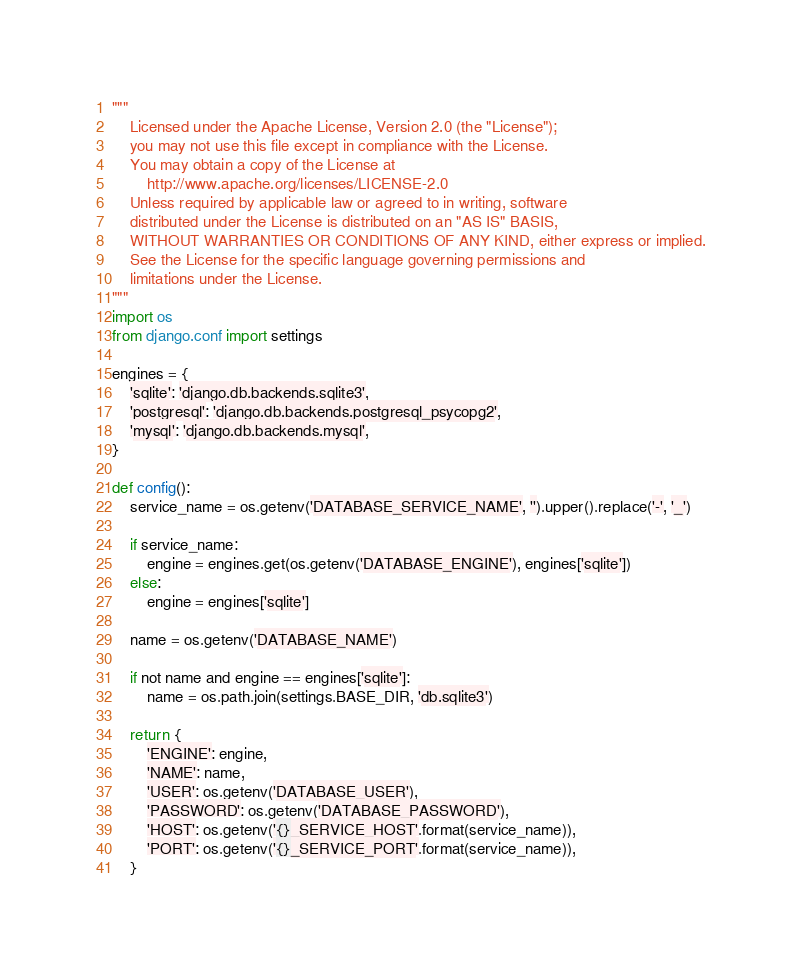Convert code to text. <code><loc_0><loc_0><loc_500><loc_500><_Python_>"""
    Licensed under the Apache License, Version 2.0 (the "License");
    you may not use this file except in compliance with the License.
    You may obtain a copy of the License at
        http://www.apache.org/licenses/LICENSE-2.0
    Unless required by applicable law or agreed to in writing, software
    distributed under the License is distributed on an "AS IS" BASIS,
    WITHOUT WARRANTIES OR CONDITIONS OF ANY KIND, either express or implied.
    See the License for the specific language governing permissions and
    limitations under the License.
"""
import os
from django.conf import settings

engines = {
    'sqlite': 'django.db.backends.sqlite3',
    'postgresql': 'django.db.backends.postgresql_psycopg2',
    'mysql': 'django.db.backends.mysql',
}

def config():
    service_name = os.getenv('DATABASE_SERVICE_NAME', '').upper().replace('-', '_')
    
    if service_name:
        engine = engines.get(os.getenv('DATABASE_ENGINE'), engines['sqlite'])
    else:
        engine = engines['sqlite']
    
    name = os.getenv('DATABASE_NAME')
    
    if not name and engine == engines['sqlite']:
        name = os.path.join(settings.BASE_DIR, 'db.sqlite3')
    
    return {
        'ENGINE': engine,
        'NAME': name,
        'USER': os.getenv('DATABASE_USER'),
        'PASSWORD': os.getenv('DATABASE_PASSWORD'),
        'HOST': os.getenv('{}_SERVICE_HOST'.format(service_name)),
        'PORT': os.getenv('{}_SERVICE_PORT'.format(service_name)),
    }
</code> 